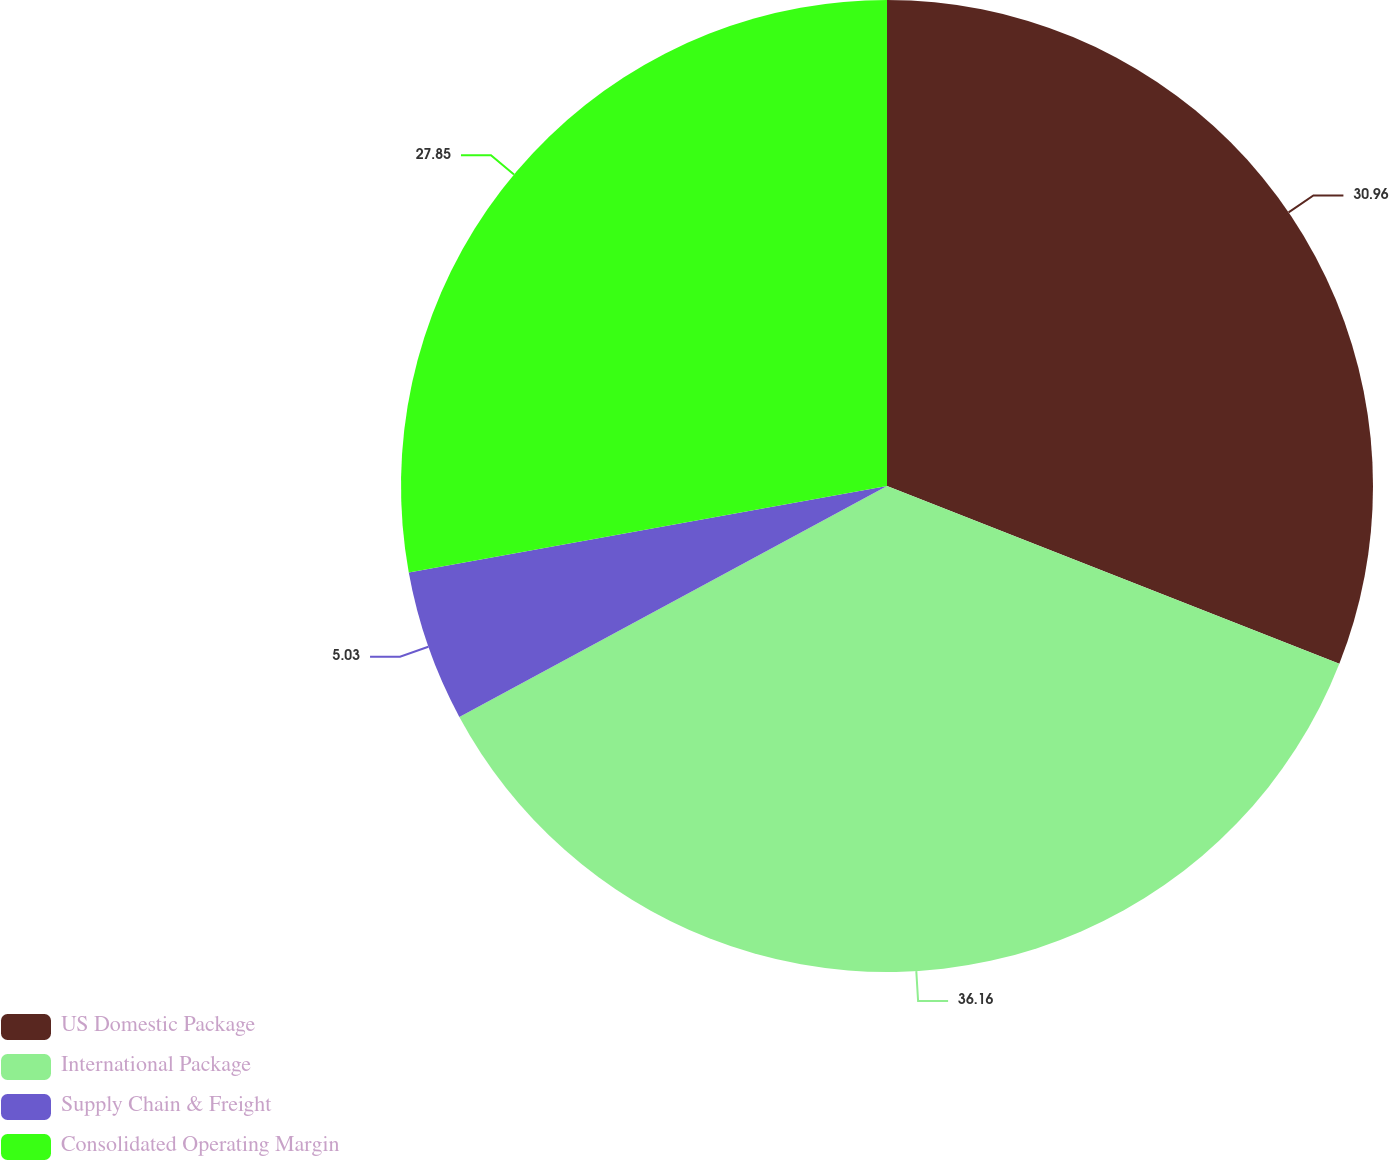Convert chart to OTSL. <chart><loc_0><loc_0><loc_500><loc_500><pie_chart><fcel>US Domestic Package<fcel>International Package<fcel>Supply Chain & Freight<fcel>Consolidated Operating Margin<nl><fcel>30.96%<fcel>36.16%<fcel>5.03%<fcel>27.85%<nl></chart> 